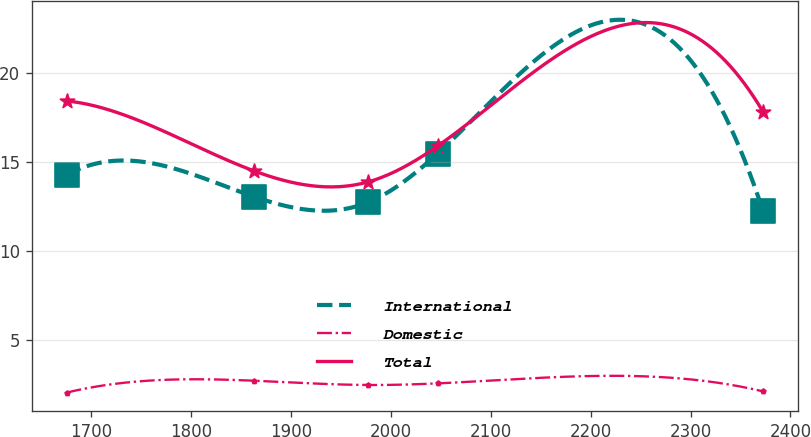Convert chart to OTSL. <chart><loc_0><loc_0><loc_500><loc_500><line_chart><ecel><fcel>International<fcel>Domestic<fcel>Total<nl><fcel>1675.05<fcel>14.28<fcel>2.03<fcel>18.45<nl><fcel>1862.83<fcel>13.06<fcel>2.7<fcel>14.51<nl><fcel>1976.94<fcel>12.74<fcel>2.46<fcel>13.89<nl><fcel>2046.68<fcel>15.49<fcel>2.55<fcel>15.91<nl><fcel>2372.5<fcel>12.27<fcel>2.1<fcel>17.85<nl></chart> 